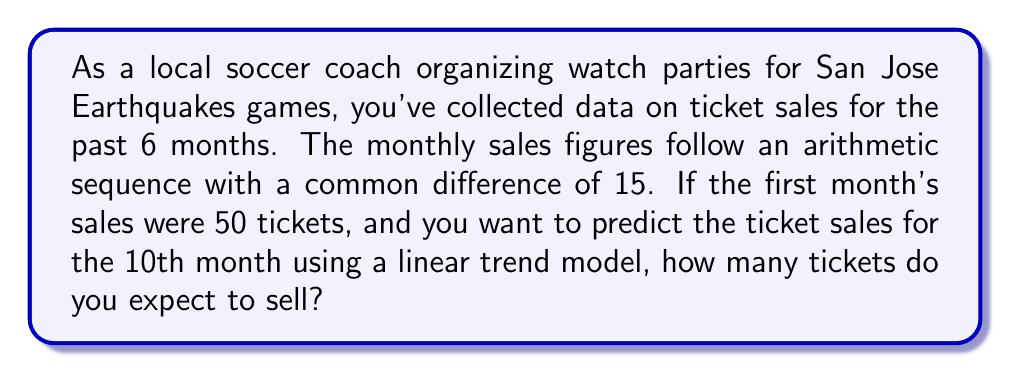Teach me how to tackle this problem. Let's approach this step-by-step using a linear trend model for time series analysis:

1) First, we need to understand the arithmetic sequence:
   - The first term $a_1 = 50$
   - The common difference $d = 15$

2) The general term of an arithmetic sequence is given by:
   $$a_n = a_1 + (n-1)d$$

3) We can use this to form our linear trend model:
   $$y_t = \beta_0 + \beta_1t$$
   Where:
   - $y_t$ is the predicted value at time $t$
   - $\beta_0$ is the y-intercept (initial value)
   - $\beta_1$ is the slope (rate of change)

4) In our case:
   - $\beta_0 = a_1 = 50$
   - $\beta_1 = d = 15$

5) So our model becomes:
   $$y_t = 50 + 15t$$

6) To predict the 10th month's sales, we substitute $t = 10$:
   $$y_{10} = 50 + 15(10) = 50 + 150 = 200$$

Therefore, based on the linear trend model, we expect to sell 200 tickets in the 10th month.
Answer: 200 tickets 